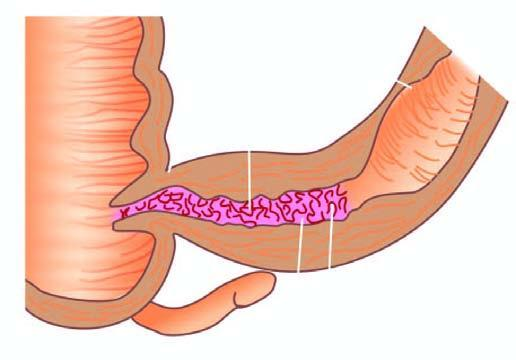does luminal surface of longitudinal cut section show segment of thickened wall with narrow lumen which is better appreciated in cross section while intervening areas of the bowel are uninvolved or skipped?
Answer the question using a single word or phrase. Yes 